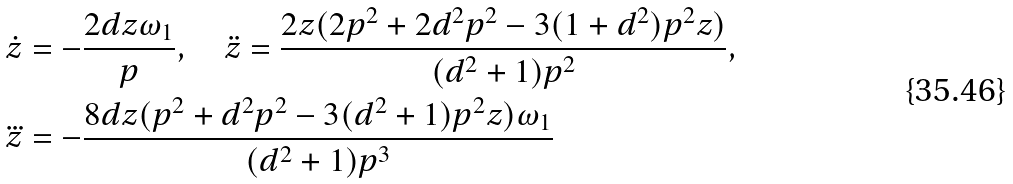<formula> <loc_0><loc_0><loc_500><loc_500>& \dot { z } = - \frac { 2 d z \omega _ { 1 } } { p } , \quad \ddot { z } = \frac { 2 z ( 2 p ^ { 2 } + 2 d ^ { 2 } p ^ { 2 } - 3 ( 1 + d ^ { 2 } ) p ^ { 2 } z ) } { ( d ^ { 2 } + 1 ) p ^ { 2 } } , \\ & \dddot { z } = - \frac { 8 d z ( p ^ { 2 } + d ^ { 2 } p ^ { 2 } - 3 ( d ^ { 2 } + 1 ) p ^ { 2 } z ) \omega _ { 1 } } { ( d ^ { 2 } + 1 ) p ^ { 3 } }</formula> 